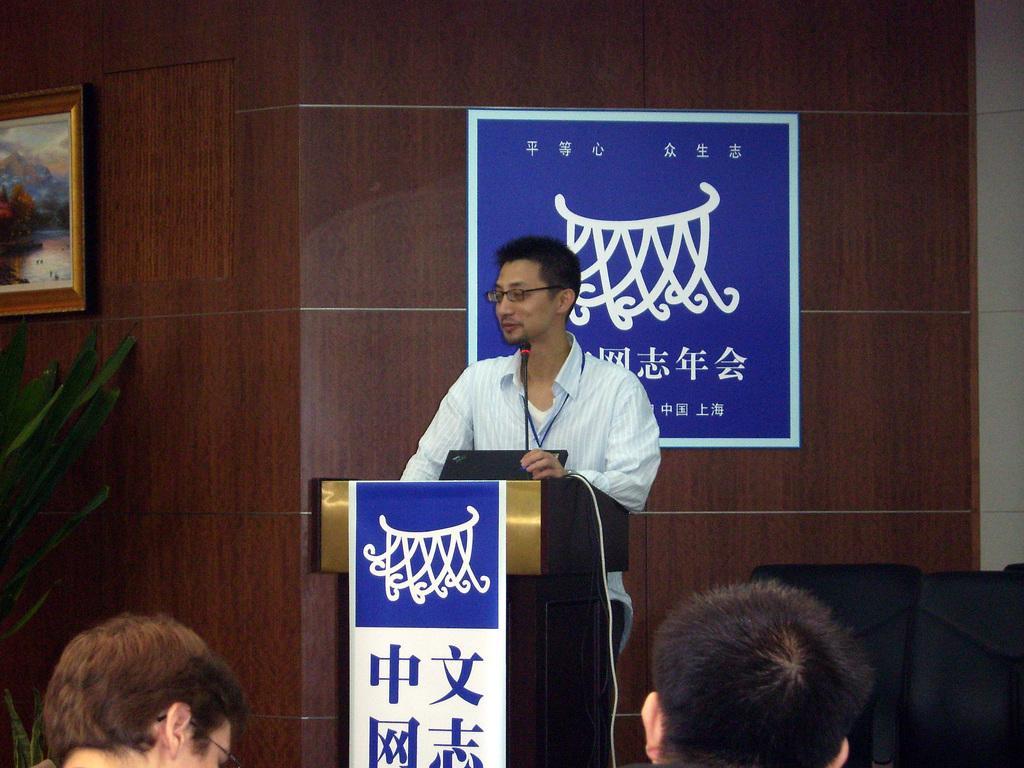Describe this image in one or two sentences. In the center of the image, we can see a person standing and wearing an id card and glasses and there is a laptop on the podium and we can see a poster and a frame on the wall and there is a houseplant, some chairs and some people. 